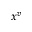Convert formula to latex. <formula><loc_0><loc_0><loc_500><loc_500>x ^ { v }</formula> 